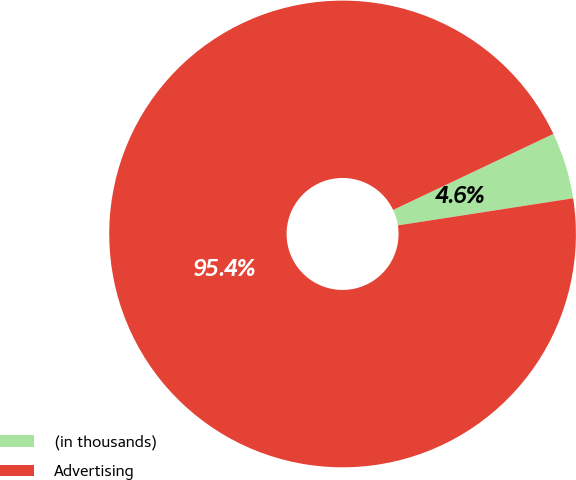<chart> <loc_0><loc_0><loc_500><loc_500><pie_chart><fcel>(in thousands)<fcel>Advertising<nl><fcel>4.61%<fcel>95.39%<nl></chart> 